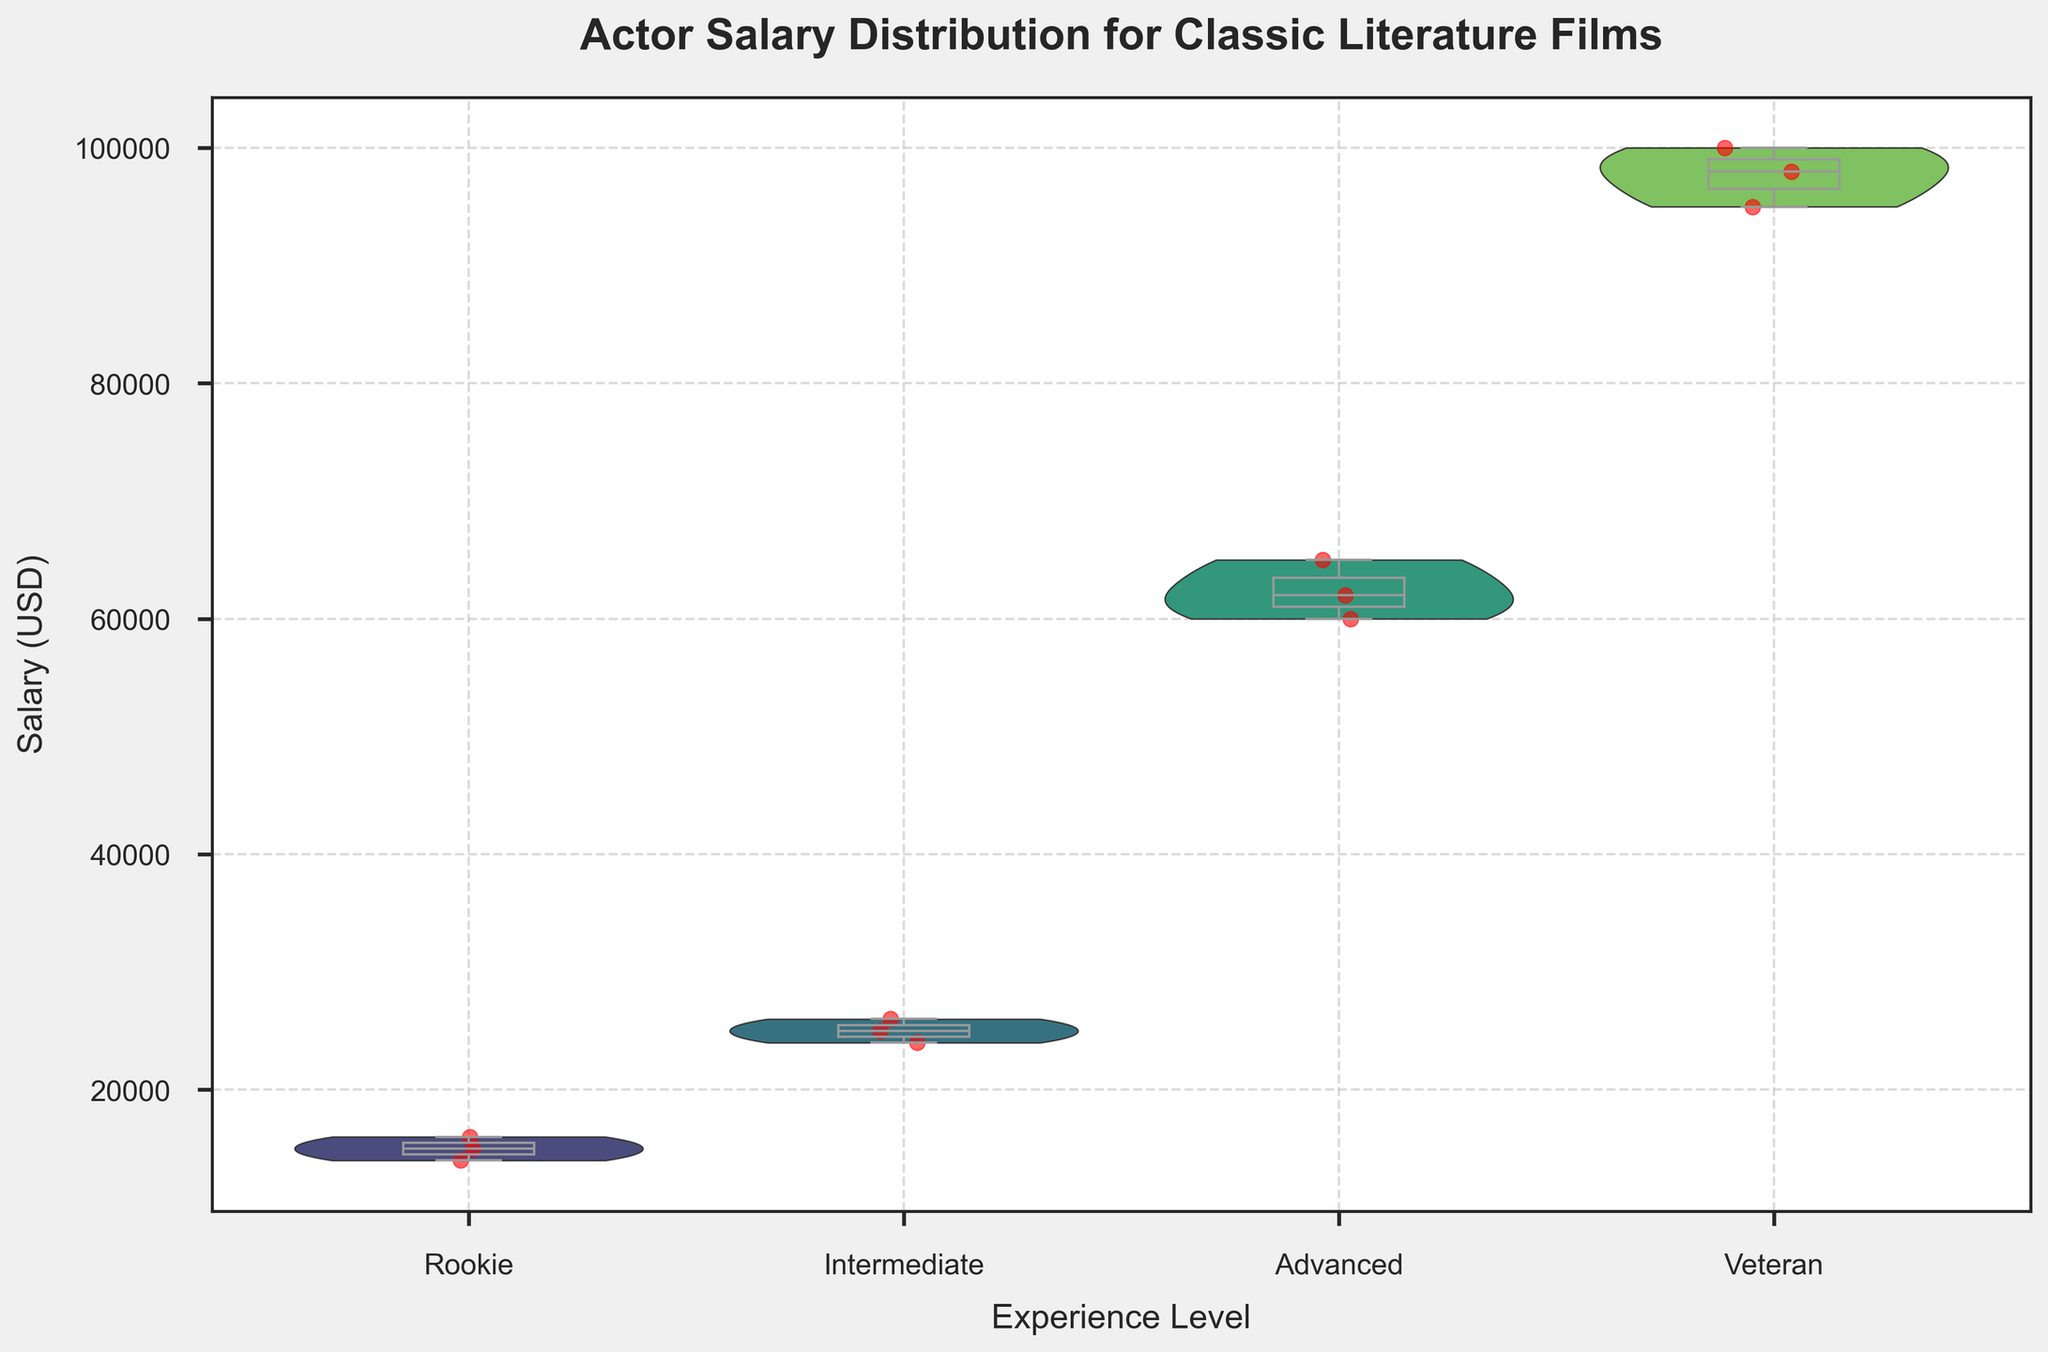What is the title of the plot? The title of the plot is written at the top and is generally the largest text element in the figure. It helps viewers understand the overall theme or subject of the plot.
Answer: Actor Salary Distribution for Classic Literature Films How are the salaries distributed for Rookie actors? Look at the section labeled "Rookie" on the x-axis of the plot. The violin plot shows the density of the salary distribution, with the widest part indicating the most common salaries. The overlaid box plot provides additional information, such as the median and quartiles.
Answer: The salaries for Rookie actors are mostly between $14,000 and $16,000 Where is the median salary for Intermediate actors? The median is shown by the line inside the box of the box plot within the violin plot. For Intermediate actors, locate the "Intermediate" section on the x-axis and find the line within the box plot.
Answer: Around $25,000 Which experience level has the highest salaries? Compare the distributions across the different experience levels on the y-axis. The highest salaries can be identified where the violin plot extends the most upwards.
Answer: Veteran What is the interquartile range (IQR) for Advanced actors? The IQR is represented by the height of the box in the box plot, which extends from the first quartile (Q1) to the third quartile (Q3). For Advanced actors, find the height of the box in the "Advanced" section.
Answer: $60,000 to $65,000 Which experience level shows the most variability in salary? The variability in salary is indicated by the width of the violin plot and the length of the whiskers in the box plot. The experience level with the widest and longest plots has the most variability.
Answer: Veteran How does the average salary for a Veteran actor compare to that of a Rookie actor? The average can be approximated by looking at the center of the distribution within each violin plot. Veteran actors have distributions centered much higher on the y-axis compared to Rookie actors.
Answer: Significantly higher Is there any overlap in the salary ranges of Intermediate and Advanced actors? Check if there are any areas where the salary distributions of Intermediate and Advanced actors intersect along the y-axis of the violin plots.
Answer: No, there is no overlap What is the lower bound of the salary range for Veteran actors? The lower bound can be found where the bottom of the violin plot and the whisker of the box plot intersect on the y-axis for Veterans.
Answer: $95,000 Which experience level appears to have the narrowest salary distribution? The narrowest salary distribution can be identified by finding the section with the smallest width of the violin plot on the x-axis.
Answer: Intermediate 